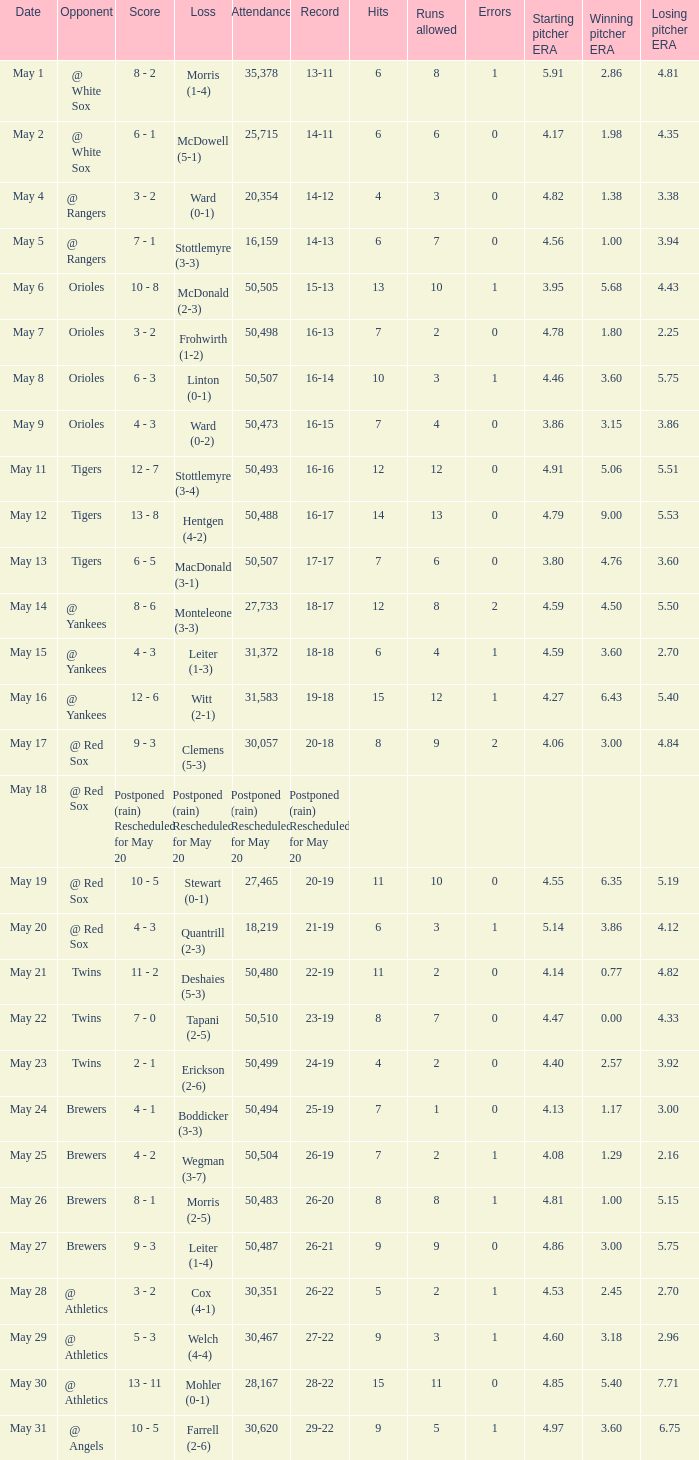On what date was their record 26-19? May 25. 